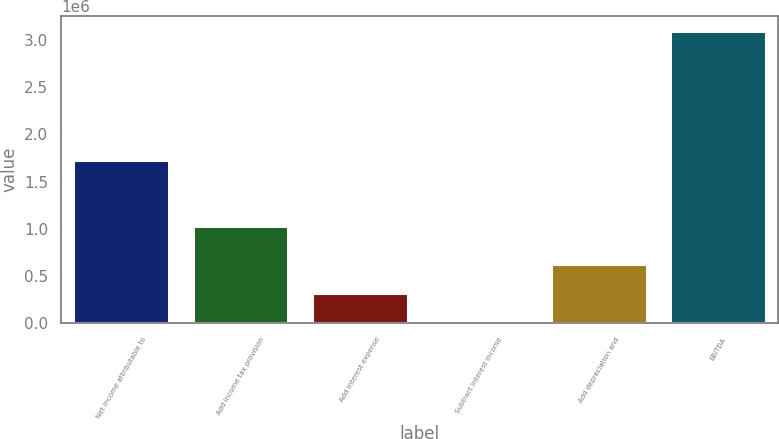Convert chart. <chart><loc_0><loc_0><loc_500><loc_500><bar_chart><fcel>Net income attributable to<fcel>Add income tax provision<fcel>Add interest expense<fcel>Subtract interest income<fcel>Add depreciation and<fcel>EBITDA<nl><fcel>1.72717e+06<fcel>1.02796e+06<fcel>314048<fcel>4786<fcel>623309<fcel>3.0974e+06<nl></chart> 